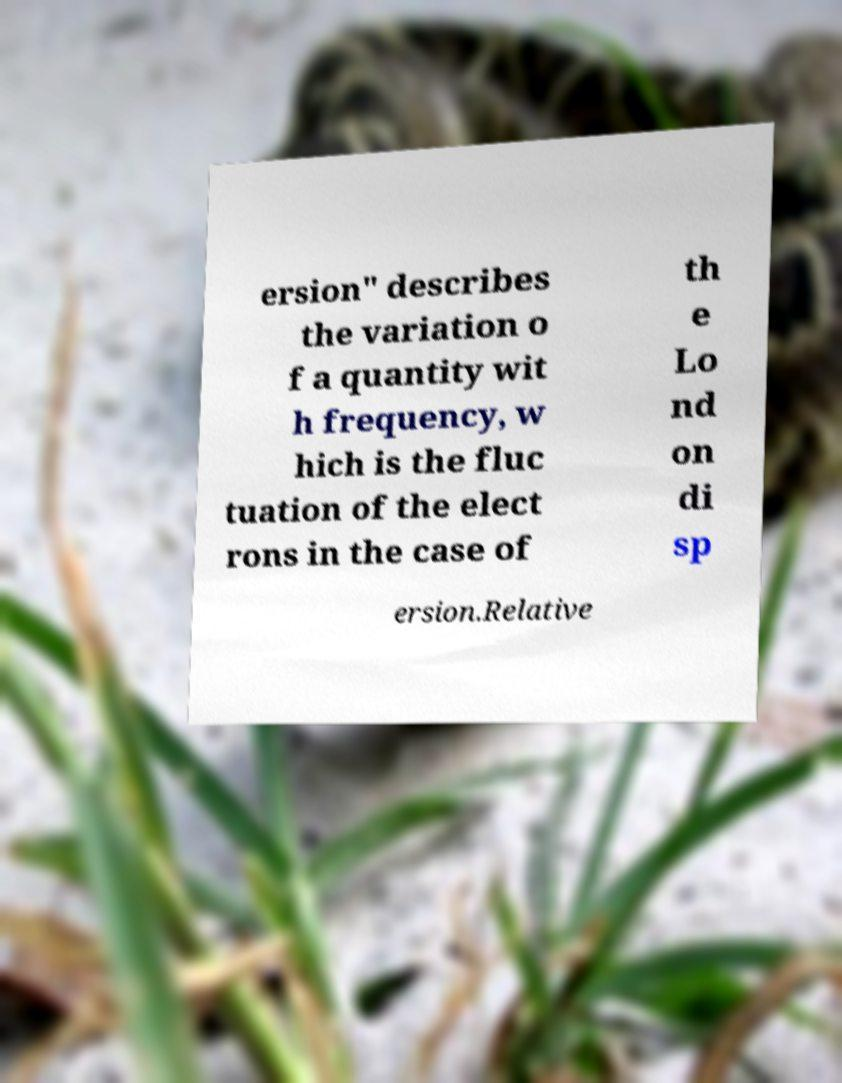There's text embedded in this image that I need extracted. Can you transcribe it verbatim? ersion" describes the variation o f a quantity wit h frequency, w hich is the fluc tuation of the elect rons in the case of th e Lo nd on di sp ersion.Relative 